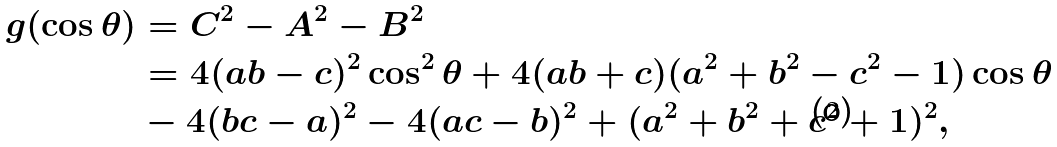Convert formula to latex. <formula><loc_0><loc_0><loc_500><loc_500>g ( \cos \theta ) & = C ^ { 2 } - A ^ { 2 } - B ^ { 2 } \\ & = 4 ( a b - c ) ^ { 2 } \cos ^ { 2 } \theta + 4 ( a b + c ) ( a ^ { 2 } + b ^ { 2 } - c ^ { 2 } - 1 ) \cos \theta \\ & - 4 ( b c - a ) ^ { 2 } - 4 ( a c - b ) ^ { 2 } + ( a ^ { 2 } + b ^ { 2 } + c ^ { 2 } + 1 ) ^ { 2 } ,</formula> 